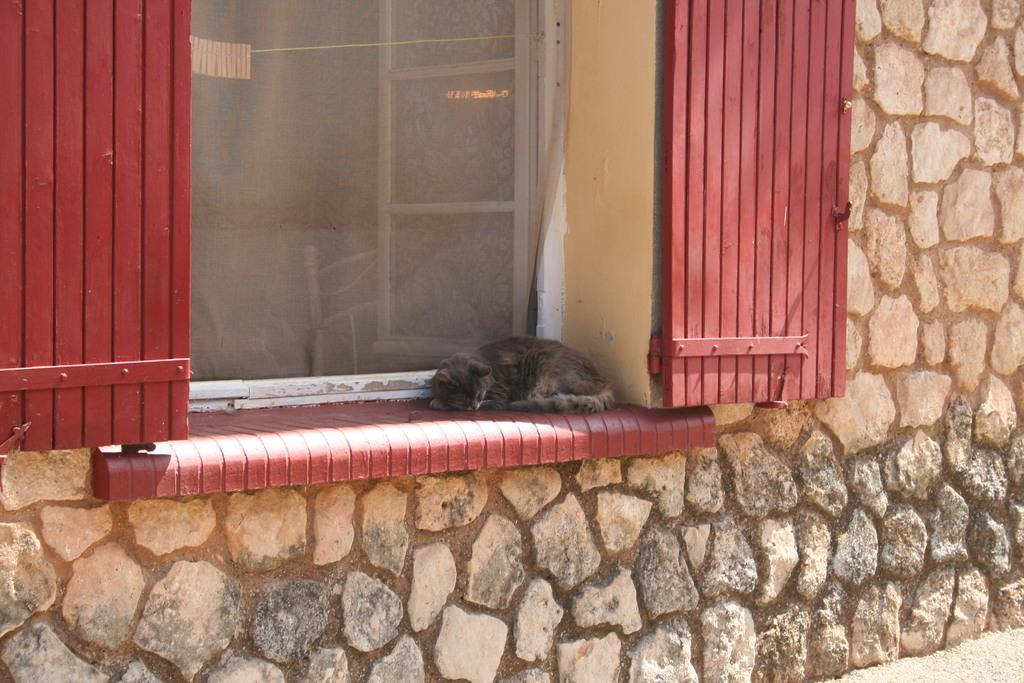What animal can be seen in the image? There is a cat in the image. What is the cat doing in the image? The cat is sleeping. Where is the cat located in the image? The cat is on a window wall. What type of doors are visible in the image? There are window doors in the image. What is the color of the window doors? The window doors are red in color. What material is the window wall made of? The window wall is made of stone. What type of disease is affecting the cat in the image? There is no indication of any disease affecting the cat in the image; it is simply sleeping on the window wall. 